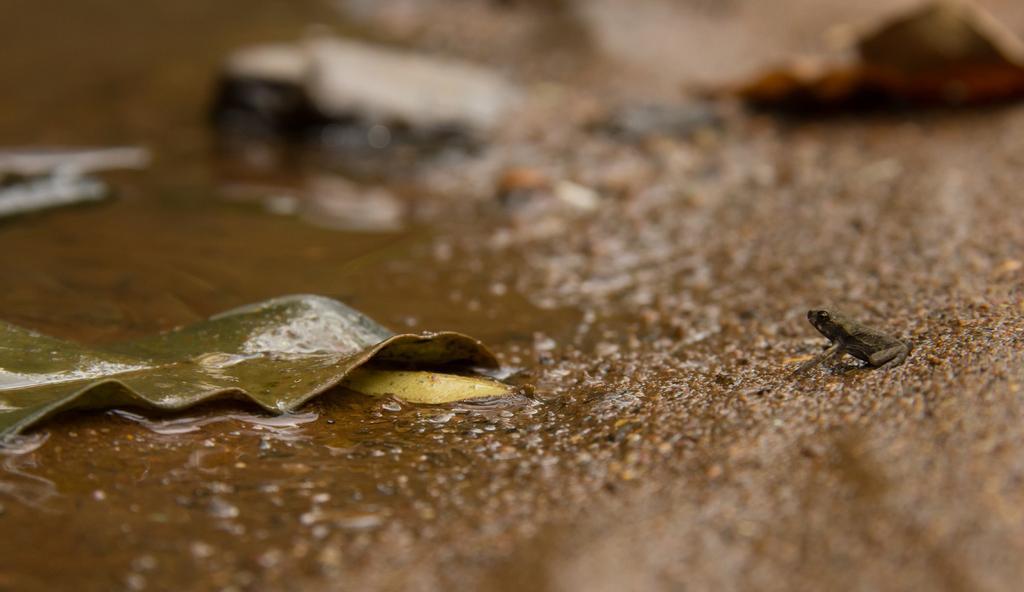Can you describe this image briefly? At the bottom of the image there is water and leaf and frog. 